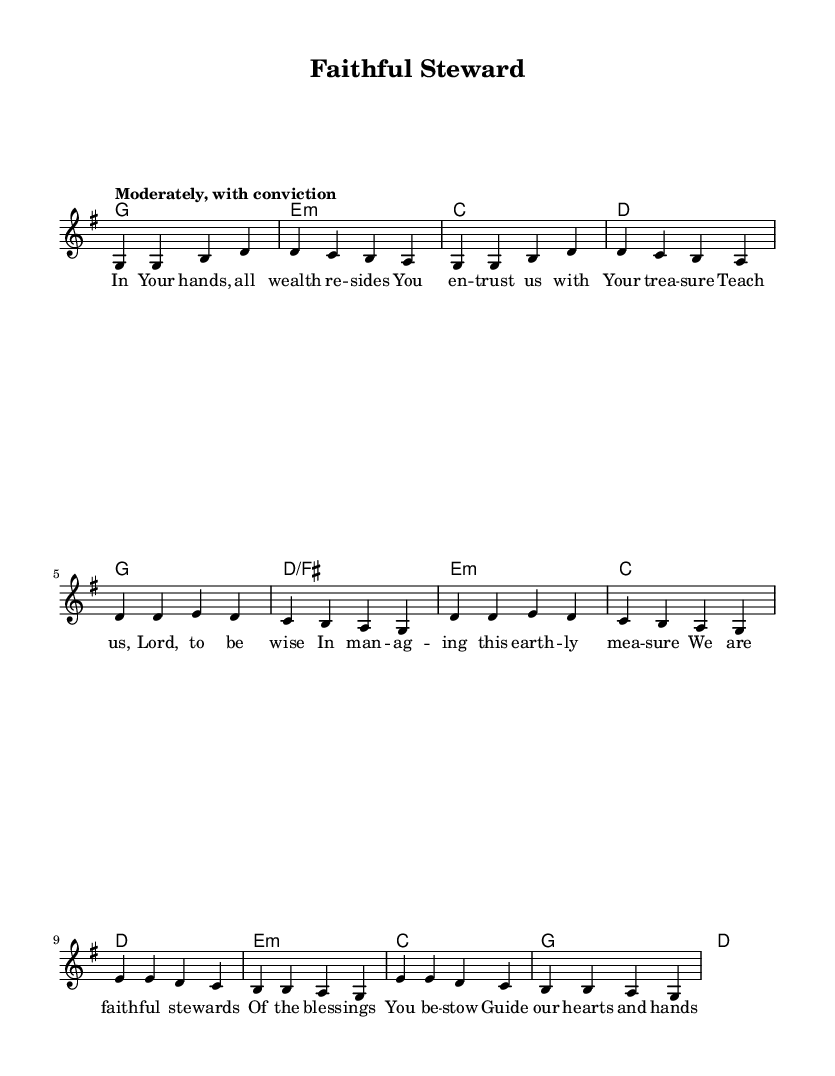What is the key signature of this music? The key signature is G major, indicated by one sharp (F#).
Answer: G major What is the time signature of this music? The time signature is 4/4, showing that each measure contains four beats and the quarter note gets one beat.
Answer: 4/4 What is the tempo marking of this music? The tempo marking is "Moderately, with conviction," suggesting a moderate pace with enthusiasm.
Answer: Moderately, with conviction How many measures are in the verse? The verse consists of four measures, as counted in the melody part.
Answer: Four What is the first word of the chorus? The first word of the chorus is "We," which begins the lyrical content of this section.
Answer: We What do the lyrics of the bridge express? The lyrics in the bridge talk about decision-making guided by wisdom, emphasizing reliance on divine guidance.
Answer: Divine guidance How does the music reflect the theme of financial stewardship? The lyrics and structure emphasize trust, wisdom in decisions, and responsibility towards wealth management, crucial for financial stewardship.
Answer: Trust, responsibility 